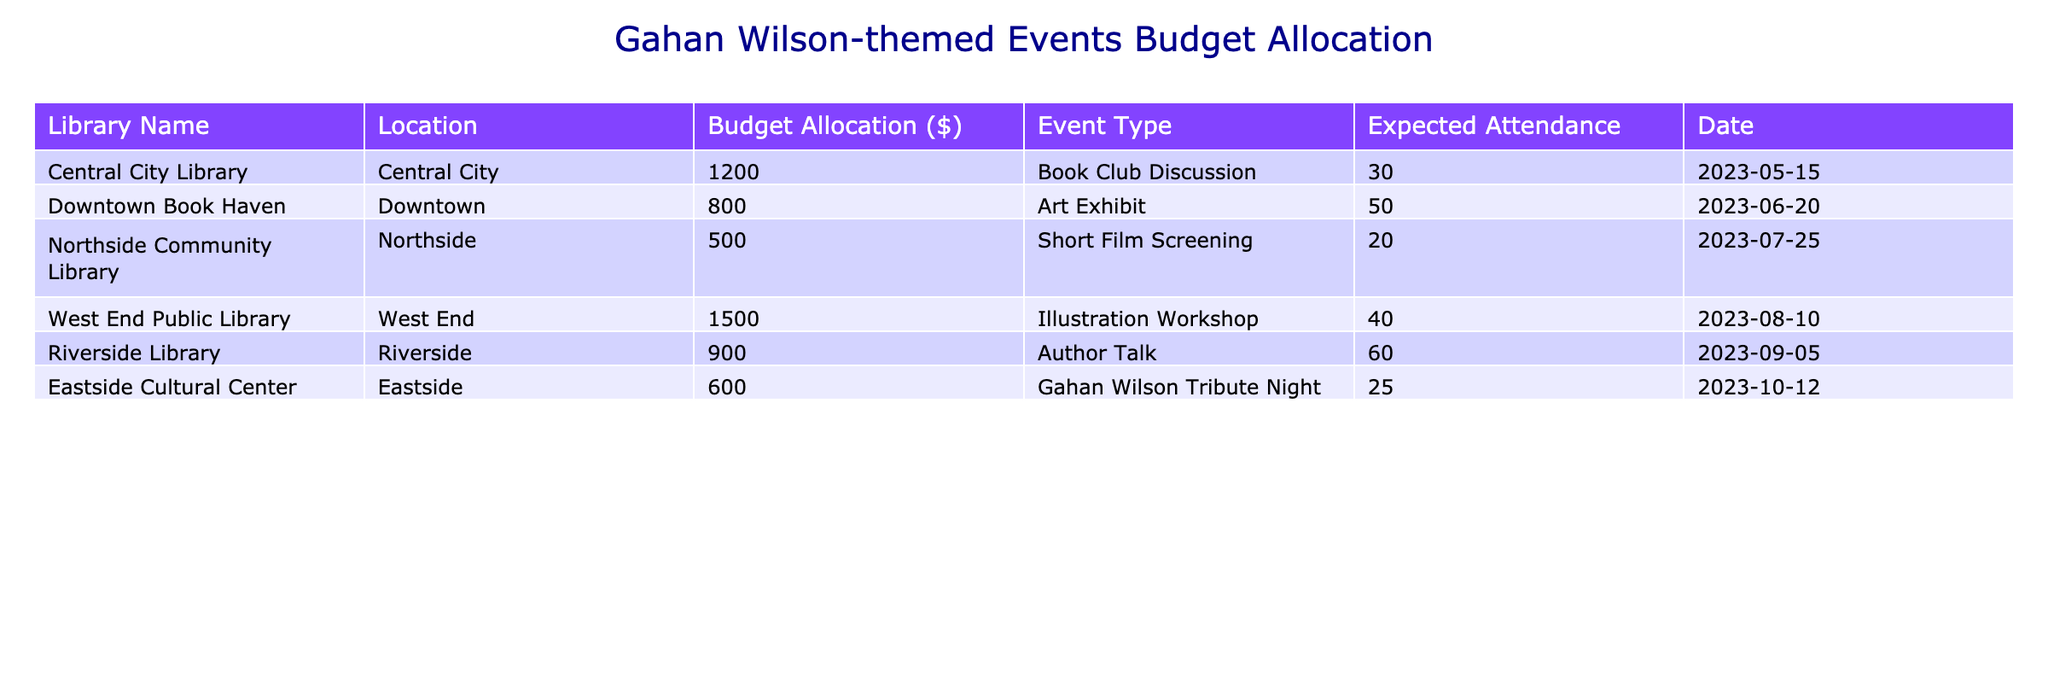What is the highest budget allocation among the events? By reviewing the "Budget Allocation" column, the highest value is 1500, which corresponds to the "Illustration Workshop" at the West End Public Library.
Answer: 1500 Which event has the lowest expected attendance? The "Short Film Screening" at Northside Community Library has the lowest expected attendance with 20 attendees.
Answer: 20 What is the total budget allocated for all events? To find the total budget, we sum all the budget allocations: 1200 + 800 + 500 + 1500 + 900 + 600 = 4500.
Answer: 4500 On what date is the Gahan Wilson Tribute Night scheduled? The date for the Gahan Wilson Tribute Night can be directly referenced from the table, which is listed as 2023-10-12.
Answer: 2023-10-12 Is there an event scheduled with an expected attendance greater than 50? Looking through the "Expected Attendance" column, the "Author Talk" at Riverside Library has an expected attendance of 60, which confirms that there is indeed an event with greater than 50 attendees.
Answer: Yes What is the average budget allocation for the events? To find the average, sum the budget allocations (4500) and divide by the number of events (6): 4500 / 6 = 750.
Answer: 750 How many libraries are organizing events with a budget allocation of less than $800? By inspecting the "Budget Allocation" column, we see that there are two libraries—Northside Community Library ($500) and Downtown Book Haven ($800)—that meet this criterion. Therefore, only Northside Community Library qualifies.
Answer: 1 What type of event is scheduled for the highest budget allocation? The "Illustration Workshop" at West End Public Library, with a budget allocation of 1500, is the highest budget allocation. Therefore, it is an illustration workshop.
Answer: Illustration Workshop Is there an event planned for June? By checking the "Date" column, we find the "Art Exhibit" at Downtown Book Haven is scheduled for June 20, confirming the presence of an event in that month.
Answer: Yes 